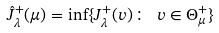<formula> <loc_0><loc_0><loc_500><loc_500>\hat { J } _ { \lambda } ^ { + } ( \mu ) = \inf \{ J _ { \lambda } ^ { + } ( v ) \colon \ v \in \Theta _ { \mu } ^ { + } \}</formula> 